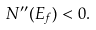<formula> <loc_0><loc_0><loc_500><loc_500>N ^ { \prime \prime } ( E _ { f } ) < 0 .</formula> 